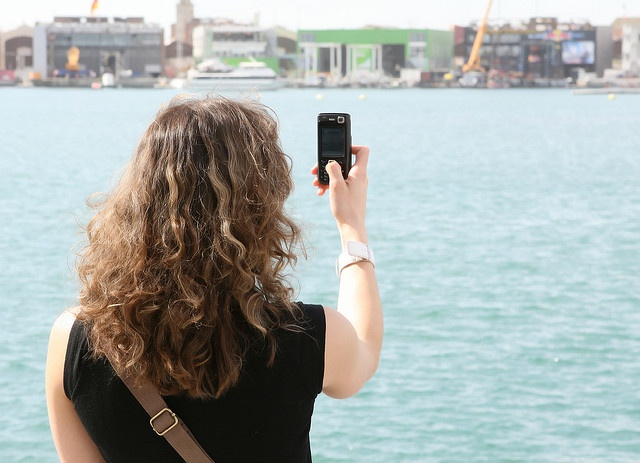Describe the objects in this image and their specific colors. I can see people in white, black, maroon, and tan tones, handbag in white, maroon, brown, and black tones, boat in white, lightgray, darkgray, and lightgreen tones, and cell phone in white, black, gray, darkgray, and maroon tones in this image. 